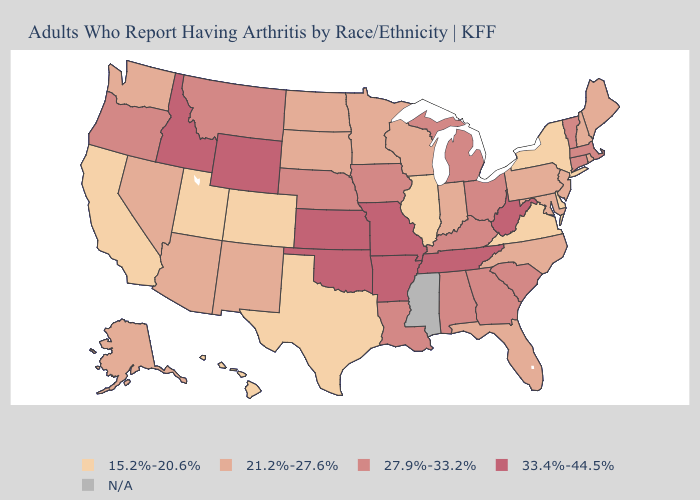Is the legend a continuous bar?
Quick response, please. No. Name the states that have a value in the range 33.4%-44.5%?
Give a very brief answer. Arkansas, Idaho, Kansas, Missouri, Oklahoma, Tennessee, West Virginia, Wyoming. What is the highest value in states that border New Hampshire?
Short answer required. 27.9%-33.2%. Does Ohio have the highest value in the MidWest?
Be succinct. No. Name the states that have a value in the range N/A?
Write a very short answer. Mississippi. What is the value of Maryland?
Give a very brief answer. 21.2%-27.6%. What is the value of Nebraska?
Be succinct. 27.9%-33.2%. What is the lowest value in the West?
Write a very short answer. 15.2%-20.6%. Does Maryland have the highest value in the South?
Keep it brief. No. What is the value of Texas?
Be succinct. 15.2%-20.6%. What is the highest value in states that border Maine?
Concise answer only. 21.2%-27.6%. Which states have the lowest value in the USA?
Quick response, please. California, Colorado, Delaware, Hawaii, Illinois, New York, Texas, Utah, Virginia. 